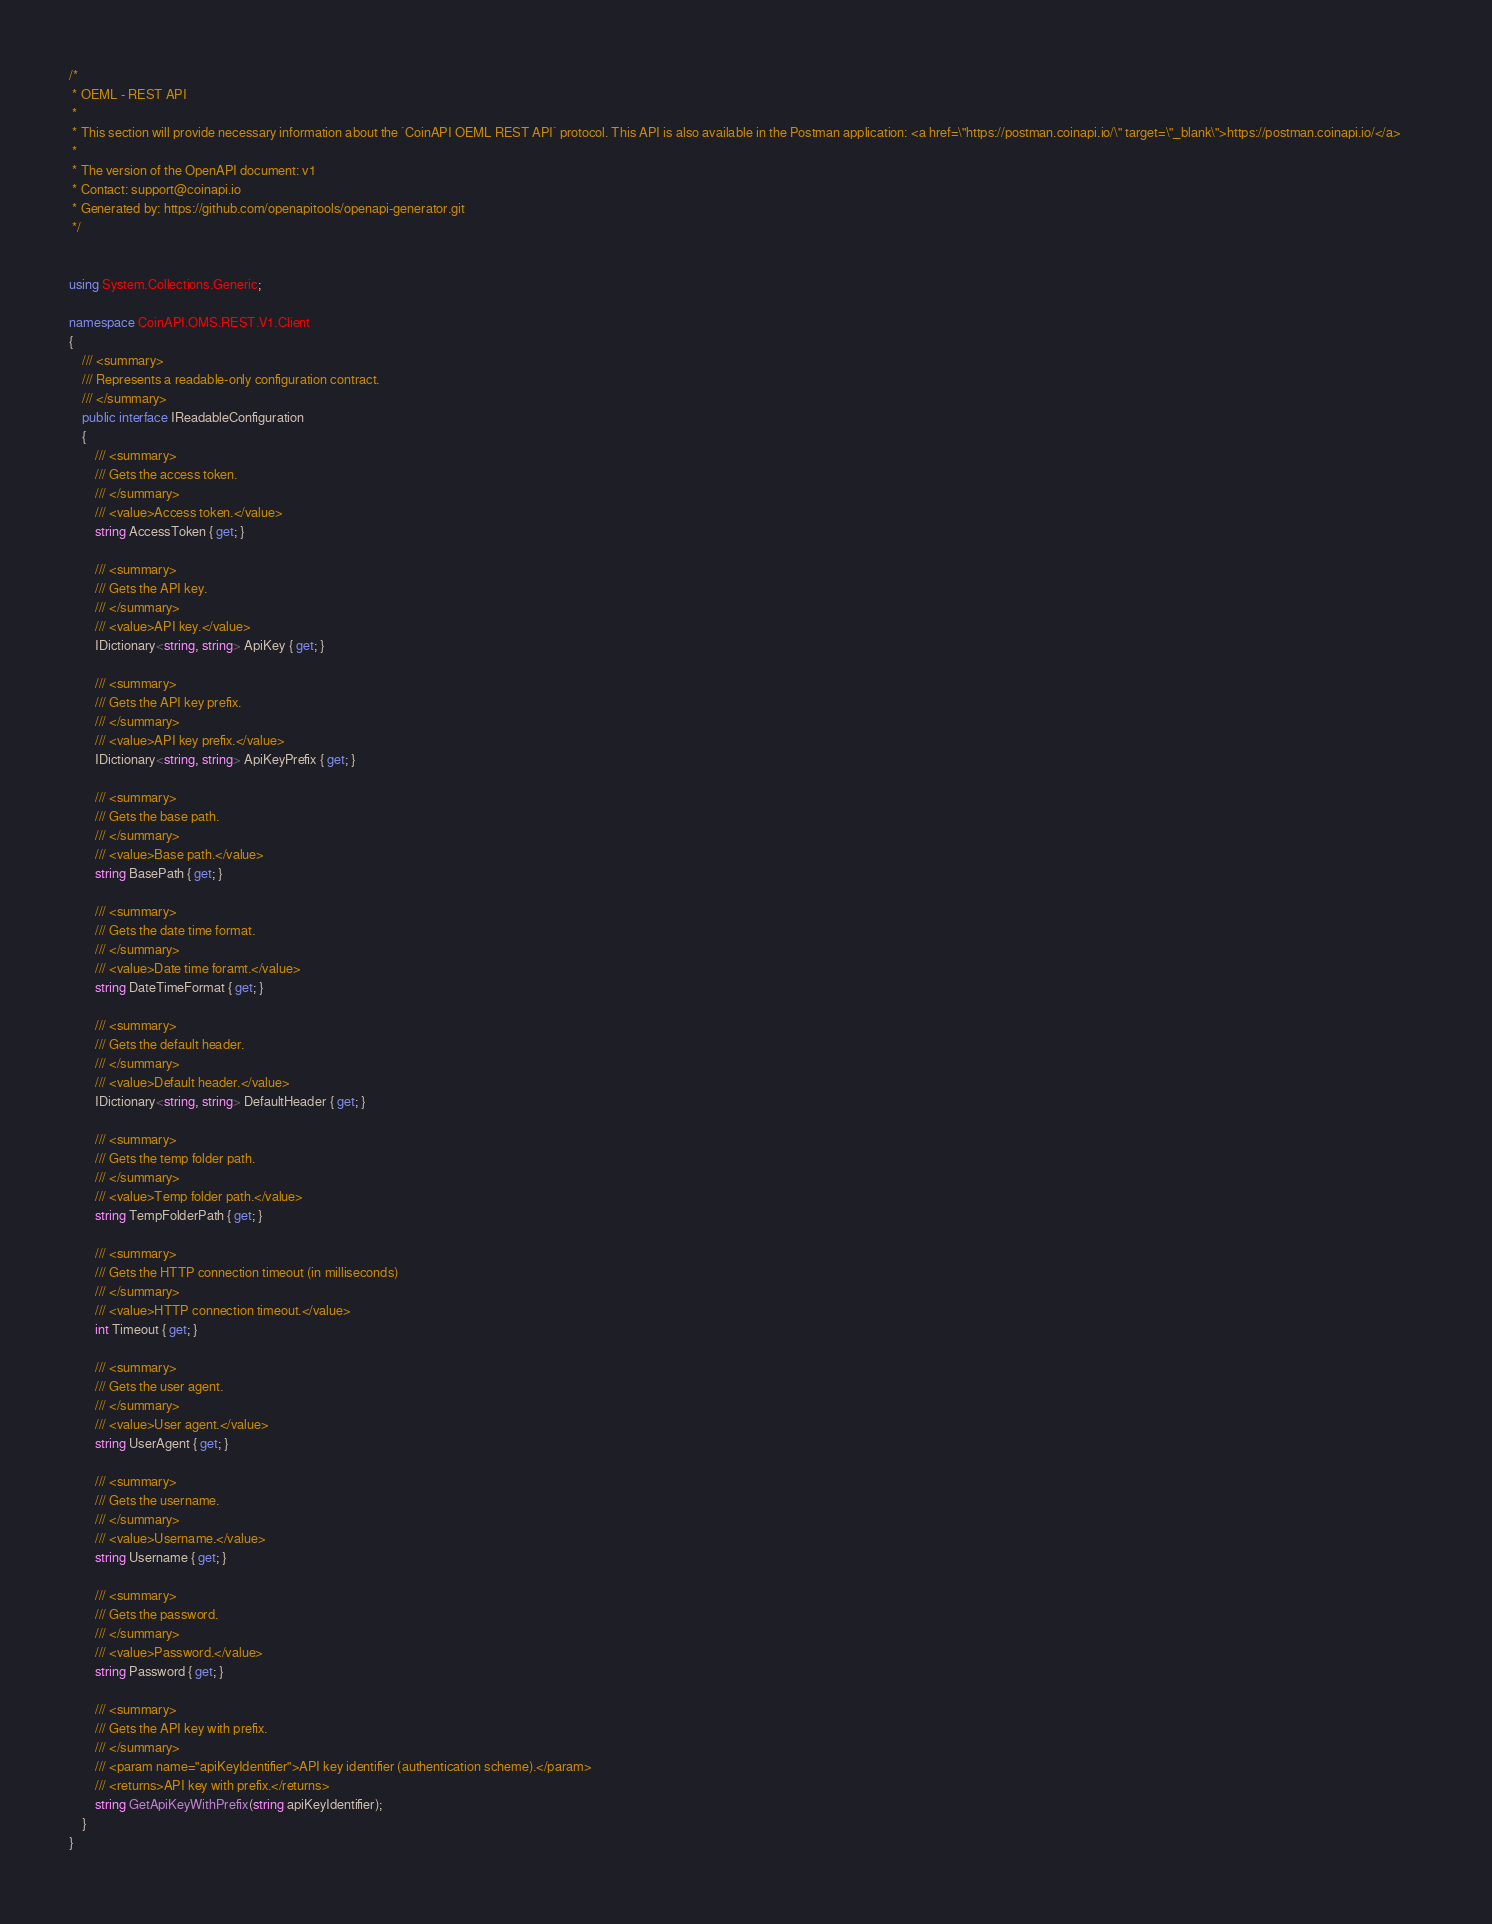Convert code to text. <code><loc_0><loc_0><loc_500><loc_500><_C#_>/* 
 * OEML - REST API
 *
 * This section will provide necessary information about the `CoinAPI OEML REST API` protocol. This API is also available in the Postman application: <a href=\"https://postman.coinapi.io/\" target=\"_blank\">https://postman.coinapi.io/</a>       
 *
 * The version of the OpenAPI document: v1
 * Contact: support@coinapi.io
 * Generated by: https://github.com/openapitools/openapi-generator.git
 */


using System.Collections.Generic;

namespace CoinAPI.OMS.REST.V1.Client
{
    /// <summary>
    /// Represents a readable-only configuration contract.
    /// </summary>
    public interface IReadableConfiguration
    {
        /// <summary>
        /// Gets the access token.
        /// </summary>
        /// <value>Access token.</value>
        string AccessToken { get; }

        /// <summary>
        /// Gets the API key.
        /// </summary>
        /// <value>API key.</value>
        IDictionary<string, string> ApiKey { get; }

        /// <summary>
        /// Gets the API key prefix.
        /// </summary>
        /// <value>API key prefix.</value>
        IDictionary<string, string> ApiKeyPrefix { get; }

        /// <summary>
        /// Gets the base path.
        /// </summary>
        /// <value>Base path.</value>
        string BasePath { get; }

        /// <summary>
        /// Gets the date time format.
        /// </summary>
        /// <value>Date time foramt.</value>
        string DateTimeFormat { get; }

        /// <summary>
        /// Gets the default header.
        /// </summary>
        /// <value>Default header.</value>
        IDictionary<string, string> DefaultHeader { get; }

        /// <summary>
        /// Gets the temp folder path.
        /// </summary>
        /// <value>Temp folder path.</value>
        string TempFolderPath { get; }

        /// <summary>
        /// Gets the HTTP connection timeout (in milliseconds)
        /// </summary>
        /// <value>HTTP connection timeout.</value>
        int Timeout { get; }

        /// <summary>
        /// Gets the user agent.
        /// </summary>
        /// <value>User agent.</value>
        string UserAgent { get; }

        /// <summary>
        /// Gets the username.
        /// </summary>
        /// <value>Username.</value>
        string Username { get; }

        /// <summary>
        /// Gets the password.
        /// </summary>
        /// <value>Password.</value>
        string Password { get; }

        /// <summary>
        /// Gets the API key with prefix.
        /// </summary>
        /// <param name="apiKeyIdentifier">API key identifier (authentication scheme).</param>
        /// <returns>API key with prefix.</returns>
        string GetApiKeyWithPrefix(string apiKeyIdentifier);
    }
}
</code> 